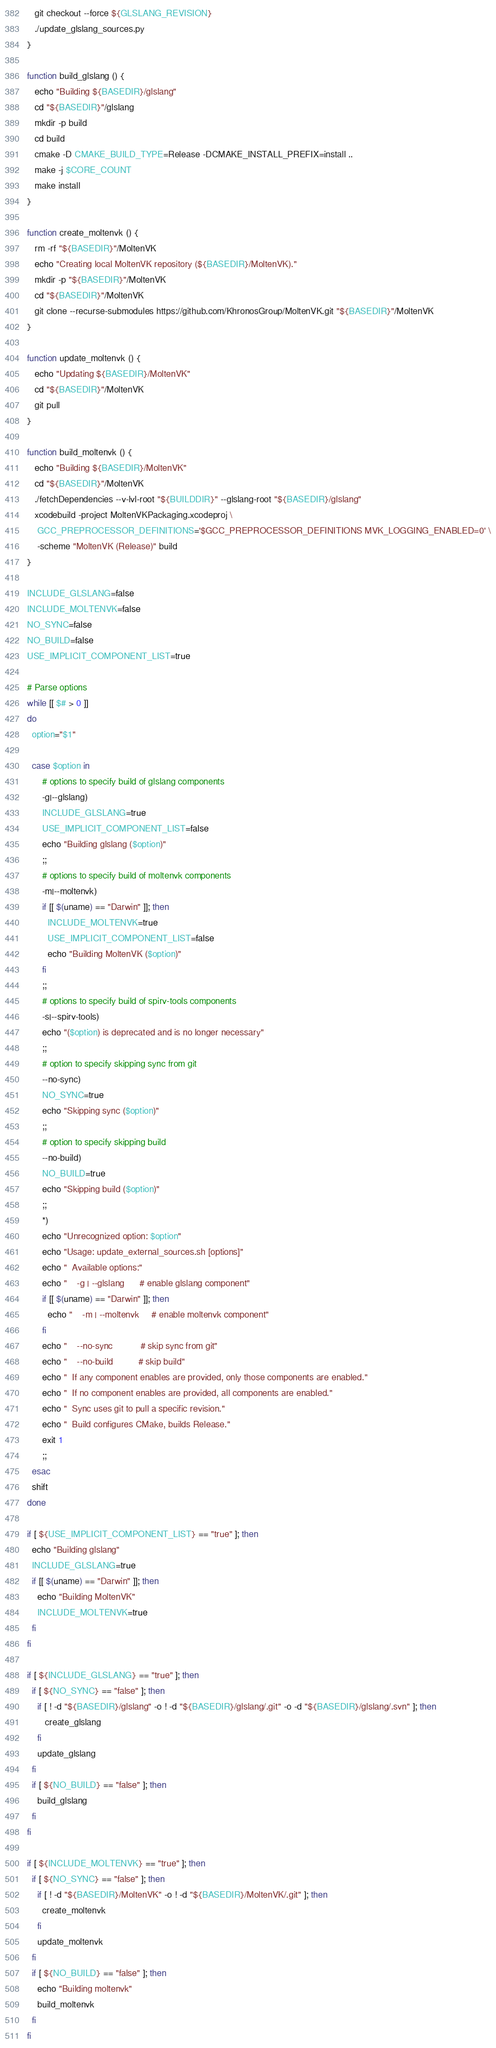<code> <loc_0><loc_0><loc_500><loc_500><_Bash_>   git checkout --force ${GLSLANG_REVISION}
   ./update_glslang_sources.py
}

function build_glslang () {
   echo "Building ${BASEDIR}/glslang"
   cd "${BASEDIR}"/glslang
   mkdir -p build
   cd build
   cmake -D CMAKE_BUILD_TYPE=Release -DCMAKE_INSTALL_PREFIX=install ..
   make -j $CORE_COUNT
   make install
}

function create_moltenvk () {
   rm -rf "${BASEDIR}"/MoltenVK
   echo "Creating local MoltenVK repository (${BASEDIR}/MoltenVK)."
   mkdir -p "${BASEDIR}"/MoltenVK
   cd "${BASEDIR}"/MoltenVK
   git clone --recurse-submodules https://github.com/KhronosGroup/MoltenVK.git "${BASEDIR}"/MoltenVK
}

function update_moltenvk () {
   echo "Updating ${BASEDIR}/MoltenVK"
   cd "${BASEDIR}"/MoltenVK
   git pull
}

function build_moltenvk () {
   echo "Building ${BASEDIR}/MoltenVK"
   cd "${BASEDIR}"/MoltenVK
   ./fetchDependencies --v-lvl-root "${BUILDDIR}" --glslang-root "${BASEDIR}/glslang"
   xcodebuild -project MoltenVKPackaging.xcodeproj \
    GCC_PREPROCESSOR_DEFINITIONS='$GCC_PREPROCESSOR_DEFINITIONS MVK_LOGGING_ENABLED=0' \
    -scheme "MoltenVK (Release)" build
}

INCLUDE_GLSLANG=false
INCLUDE_MOLTENVK=false
NO_SYNC=false
NO_BUILD=false
USE_IMPLICIT_COMPONENT_LIST=true

# Parse options
while [[ $# > 0 ]]
do
  option="$1"

  case $option in
      # options to specify build of glslang components
      -g|--glslang)
      INCLUDE_GLSLANG=true
      USE_IMPLICIT_COMPONENT_LIST=false
      echo "Building glslang ($option)"
      ;;
      # options to specify build of moltenvk components
      -m|--moltenvk)
      if [[ $(uname) == "Darwin" ]]; then
        INCLUDE_MOLTENVK=true
        USE_IMPLICIT_COMPONENT_LIST=false
        echo "Building MoltenVK ($option)"
      fi
      ;;
      # options to specify build of spirv-tools components
      -s|--spirv-tools)
      echo "($option) is deprecated and is no longer necessary"
      ;;
      # option to specify skipping sync from git
      --no-sync)
      NO_SYNC=true
      echo "Skipping sync ($option)"
      ;;
      # option to specify skipping build
      --no-build)
      NO_BUILD=true
      echo "Skipping build ($option)"
      ;;
      *)
      echo "Unrecognized option: $option"
      echo "Usage: update_external_sources.sh [options]"
      echo "  Available options:"
      echo "    -g | --glslang      # enable glslang component"
      if [[ $(uname) == "Darwin" ]]; then
        echo "    -m | --moltenvk     # enable moltenvk component"
      fi
      echo "    --no-sync           # skip sync from git"
      echo "    --no-build          # skip build"
      echo "  If any component enables are provided, only those components are enabled."
      echo "  If no component enables are provided, all components are enabled."
      echo "  Sync uses git to pull a specific revision."
      echo "  Build configures CMake, builds Release."
      exit 1
      ;;
  esac
  shift
done

if [ ${USE_IMPLICIT_COMPONENT_LIST} == "true" ]; then
  echo "Building glslang"
  INCLUDE_GLSLANG=true
  if [[ $(uname) == "Darwin" ]]; then
    echo "Building MoltenVK"
    INCLUDE_MOLTENVK=true
  fi
fi

if [ ${INCLUDE_GLSLANG} == "true" ]; then
  if [ ${NO_SYNC} == "false" ]; then
    if [ ! -d "${BASEDIR}/glslang" -o ! -d "${BASEDIR}/glslang/.git" -o -d "${BASEDIR}/glslang/.svn" ]; then
       create_glslang
    fi
    update_glslang
  fi
  if [ ${NO_BUILD} == "false" ]; then
    build_glslang
  fi
fi

if [ ${INCLUDE_MOLTENVK} == "true" ]; then
  if [ ${NO_SYNC} == "false" ]; then
    if [ ! -d "${BASEDIR}/MoltenVK" -o ! -d "${BASEDIR}/MoltenVK/.git" ]; then
      create_moltenvk
    fi
    update_moltenvk
  fi
  if [ ${NO_BUILD} == "false" ]; then
    echo "Building moltenvk"
    build_moltenvk
  fi
fi

</code> 